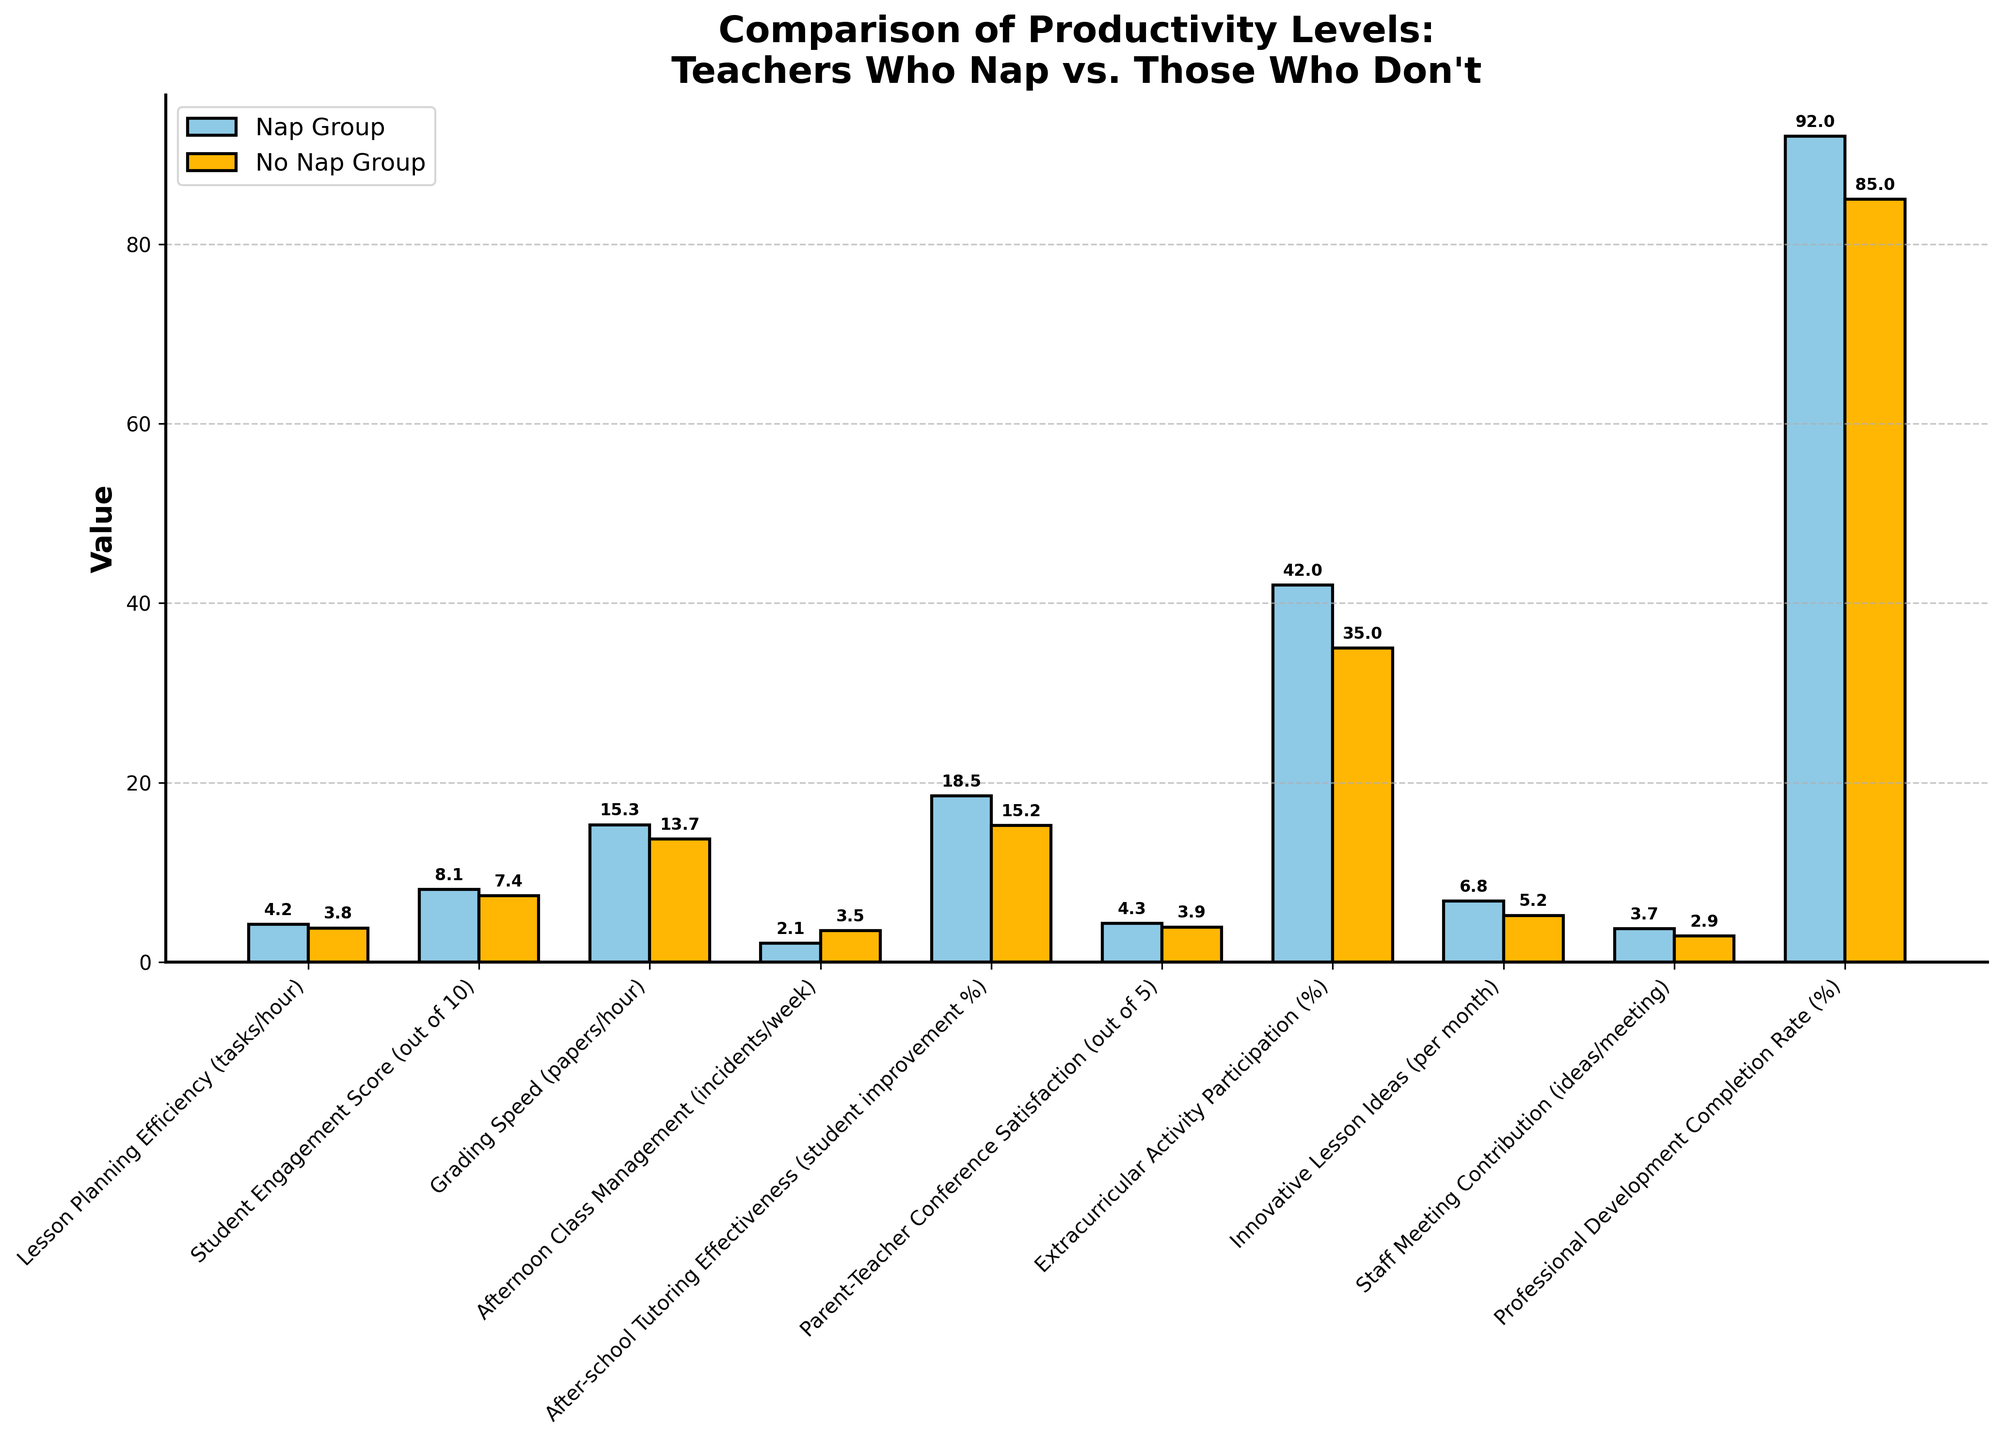What's the difference in Grading Speed between teachers who nap and those who don't? To find the difference in Grading Speed (papers/hour), subtract the value for "No Nap Group" (13.7) from the value for "Nap Group" (15.3). Therefore, the difference is 15.3 - 13.7 = 1.6.
Answer: 1.6 Which group has a higher Student Engagement Score? By comparing the heights of the bars for "Student Engagement Score," the bar for "Nap Group" (8.1) is taller than the bar for "No Nap Group" (7.4). Thus, the "Nap Group" has a higher score.
Answer: Nap Group Among the subjects compared, which has the most significant difference between the two groups? Assess the differences for each subject by visually comparing the heights of the bars. The largest difference is found in "Afternoon Class Management," where the "Nap Group" has a lower number of incidents (2.1 compared to 3.5). The difference is 3.5 - 2.1 = 1.4.
Answer: Afternoon Class Management What is the ratio of the Afternoon Class Management incidents for the Nap Group to the No Nap Group? To find the ratio, divide the number of incidents for the "Nap Group" (2.1) by the number for the "No Nap Group" (3.5). Thus, the ratio is 2.1 / 3.5 = 0.6.
Answer: 0.6 Which metric shows the smallest difference between the two groups? Compare the differences between the two bars for each metric. The smallest difference is observed in "Parent-Teacher Conference Satisfaction," with values 4.3 for "Nap Group" and 3.9 for "No Nap Group," resulting in a difference of 0.4.
Answer: Parent-Teacher Conference Satisfaction Do teachers who nap have a higher After-school Tutoring Effectiveness compared to those who don't? By comparing the heights of the bars for "After-school Tutoring Effectiveness," the "Nap Group" has a higher score (18.5) than the "No Nap Group" (15.2).
Answer: Yes What's the average Professional Development Completion Rate for both groups combined? To find the average, add the completion rates for both groups and divide by 2: (92 + 85) / 2 = 177 / 2 = 88.5.
Answer: 88.5 What is the sum of the Lesson Planning Efficiency values for both groups? Add the Lesson Planning Efficiency values of the "Nap Group" (4.2) and the "No Nap Group" (3.8): 4.2 + 3.8 = 8.0.
Answer: 8.0 How many metrics show that teachers who nap have better results? Count the number of metrics where the "Nap Group" bars are higher than the "No Nap Group" bars: Lesson Planning Efficiency, Student Engagement Score, Grading Speed, After-school Tutoring Effectiveness, Parent-Teacher Conference Satisfaction, Extracurricular Activity Participation, Innovative Lesson Ideas, Staff Meeting Contribution, Professional Development Completion Rate. There are 9 metrics.
Answer: 9 Which group shows a better score in Staff Meeting Contribution? By comparing the heights of the bars for "Staff Meeting Contribution," the "Nap Group" (3.7) has a better score than the "No Nap Group" (2.9).
Answer: Nap Group 